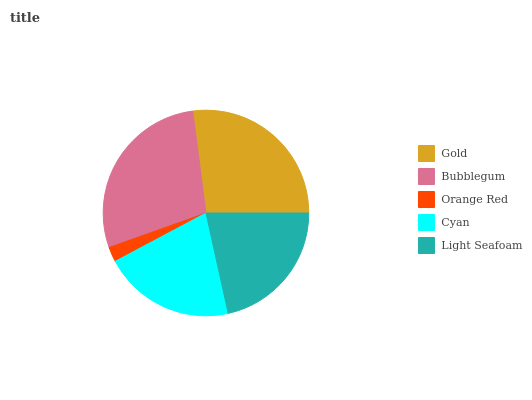Is Orange Red the minimum?
Answer yes or no. Yes. Is Bubblegum the maximum?
Answer yes or no. Yes. Is Bubblegum the minimum?
Answer yes or no. No. Is Orange Red the maximum?
Answer yes or no. No. Is Bubblegum greater than Orange Red?
Answer yes or no. Yes. Is Orange Red less than Bubblegum?
Answer yes or no. Yes. Is Orange Red greater than Bubblegum?
Answer yes or no. No. Is Bubblegum less than Orange Red?
Answer yes or no. No. Is Light Seafoam the high median?
Answer yes or no. Yes. Is Light Seafoam the low median?
Answer yes or no. Yes. Is Cyan the high median?
Answer yes or no. No. Is Orange Red the low median?
Answer yes or no. No. 